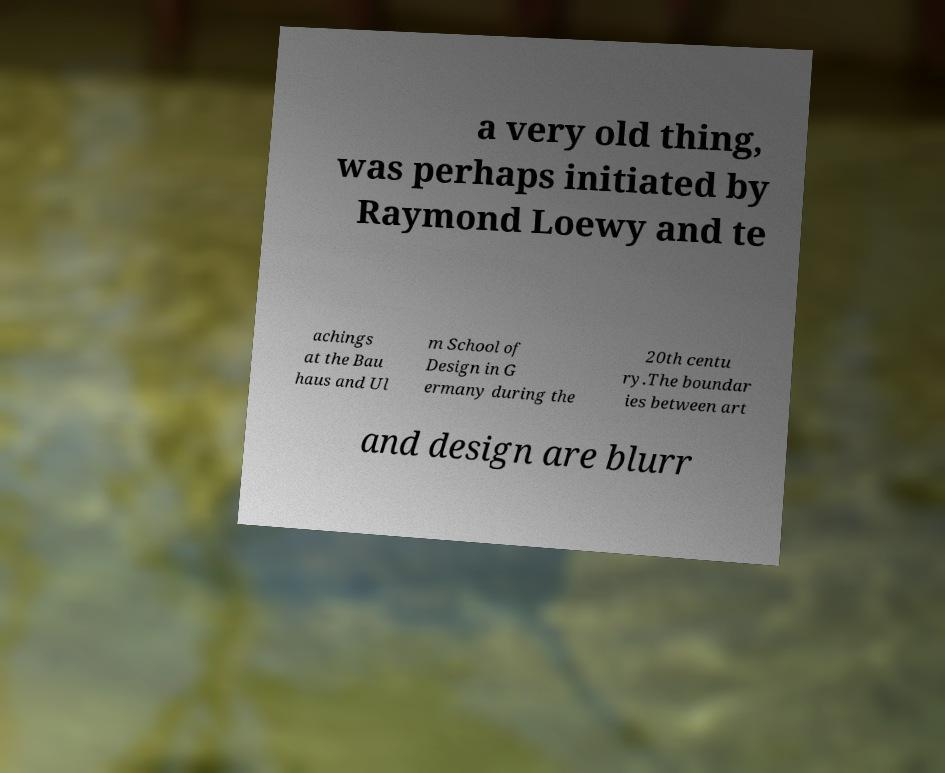Can you accurately transcribe the text from the provided image for me? a very old thing, was perhaps initiated by Raymond Loewy and te achings at the Bau haus and Ul m School of Design in G ermany during the 20th centu ry.The boundar ies between art and design are blurr 